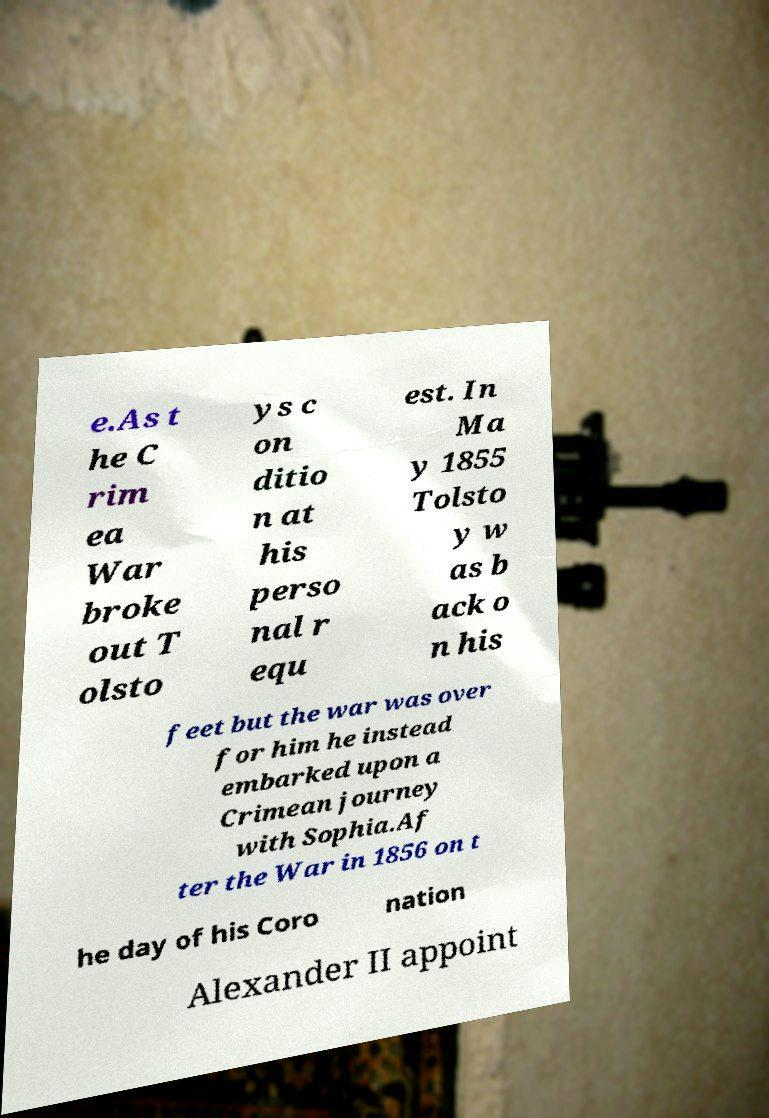Please identify and transcribe the text found in this image. e.As t he C rim ea War broke out T olsto ys c on ditio n at his perso nal r equ est. In Ma y 1855 Tolsto y w as b ack o n his feet but the war was over for him he instead embarked upon a Crimean journey with Sophia.Af ter the War in 1856 on t he day of his Coro nation Alexander II appoint 